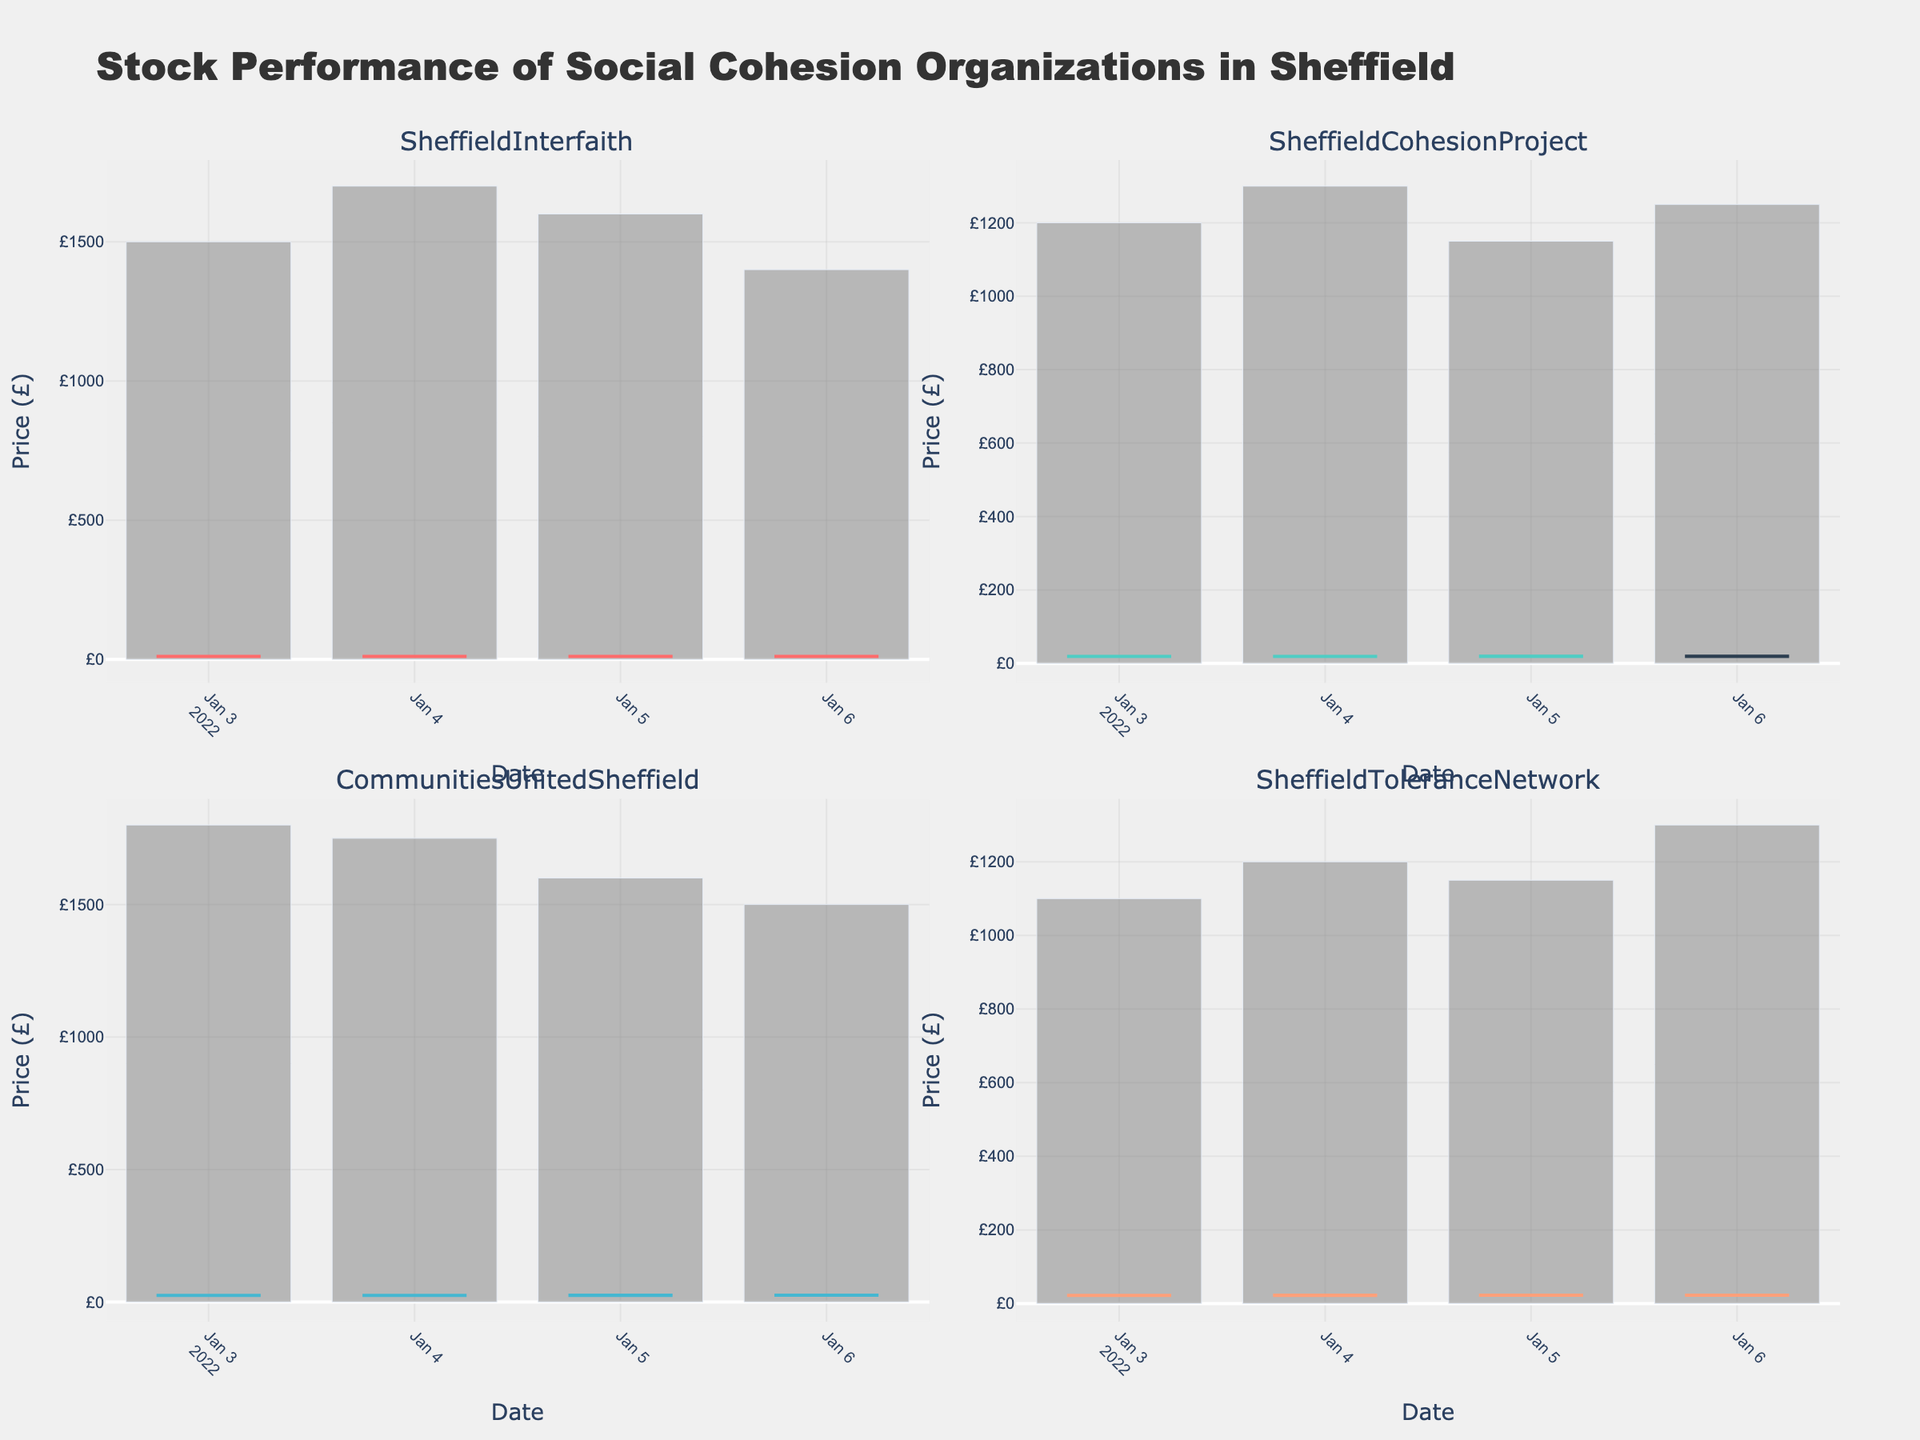What is the highest price achieved by SheffieldInterfaith? Look at the highest price bar for SheffieldInterfaith in the top-left section. The highest price candle is on 2022-01-06, showing £11.20 as the highest price.
Answer: £11.20 What is the volume of trades for SheffieldCohesionProject on 2022-01-05? Find SheffieldCohesionProject in the top-right section and locate the bar on 2022-01-05. The volume bar indicates a volume of 1150.
Answer: 1150 Which organization experienced the lowest closing price on 2022-01-03? Compare the closing prices of all organizations on 2022-01-03 in their respective sections. SheffieldInterfaith closed at £10.60, SheffieldCohesionProject at £18.90, CommunitiesUnitedSheffield at £25.40, and SheffieldToleranceNetwork at £22.25. SheffieldInterfaith has the lowest closing price.
Answer: SheffieldInterfaith Calculate the average closing price for CommunitiesUnitedSheffield from 2022-01-03 to 2022-01-06. Locate the closing prices for CommunitiesUnitedSheffield in the bottom-left section: £25.40, £25.50, £25.70, £25.80. Add these values up and divide by 4: (25.40 + 25.50 + 25.70 + 25.80) / 4 = 25.60.
Answer: £25.60 Which organization had the most stable opening prices over the given period? Compare the differences in opening prices for all organizations over the 4 days. SheffieldInterfaith: £10.50 to £11.00 (£0.50), SheffieldCohesionProject: £18.75 to £19.20 (£0.45), CommunitiesUnitedSheffield: £25.30 to £25.70 (£0.40), SheffieldToleranceNetwork: £22.15 to £22.45 (£0.30). SheffieldToleranceNetwork has the smallest range, indicating the most stability.
Answer: SheffieldToleranceNetwork Did any organization have a day where the lowest price was equal to the opening price? Observe each candlestick for all organizations. No candle has the exact same open and low prices. Therefore, no organization experienced this scenario.
Answer: No What is the total volume of trades for SheffieldToleranceNetwork from 2022-01-03 to 2022-01-06? Sum the volume bars for SheffieldToleranceNetwork in the bottom-right section: 1100, 1200, 1150, and 1300. The total volume is 1100 + 1200 + 1150 + 1300 = 4750.
Answer: 4750 Which day saw the highest closing price for SheffieldCohesionProject? Look at the closing prices for SheffieldCohesionProject in the top-right section over the 4 days: £18.90, £19.00, £19.20, £19.10. The highest closing price occurred on 2022-01-05.
Answer: 2022-01-05 Compare the price range for CommunitiesUnitedSheffield on 2022-01-03 and SheffieldToleranceNetwork on 2022-01-03. Which organization had a wider range? CommunitiesUnitedSheffield: range = high (£25.60) - low (£25.00) = £0.60. SheffieldToleranceNetwork: range = high (£22.40) - low (£21.90) = £0.50. CommunitiesUnitedSheffield had a wider range.
Answer: CommunitiesUnitedSheffield Which organization had the largest increase in closing price from 2022-01-03 to 2022-01-04? Calculate the closing price increase for each organization: SheffieldInterfaith: £10.80 - £10.60 = £0.20, SheffieldCohesionProject: £19.00 - £18.90 = £0.10, CommunitiesUnitedSheffield: £25.50 - £25.40 = £0.10, SheffieldToleranceNetwork: £22.35 - £22.25 = £0.10. SheffieldInterfaith had the largest increase in closing price.
Answer: SheffieldInterfaith 